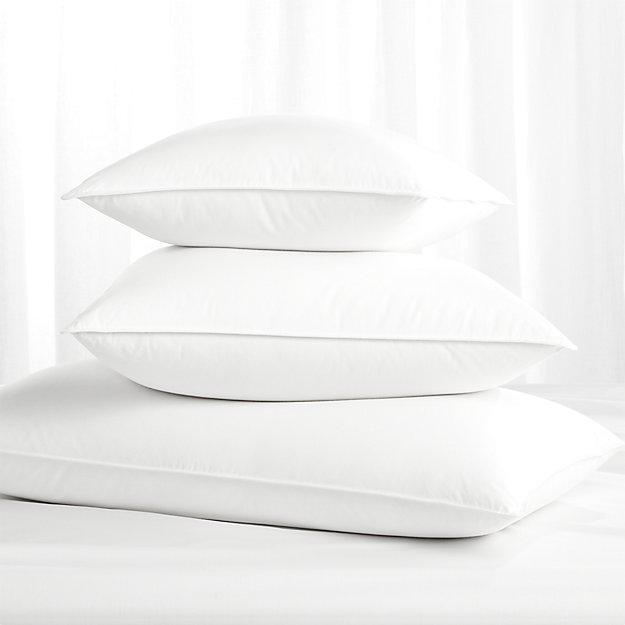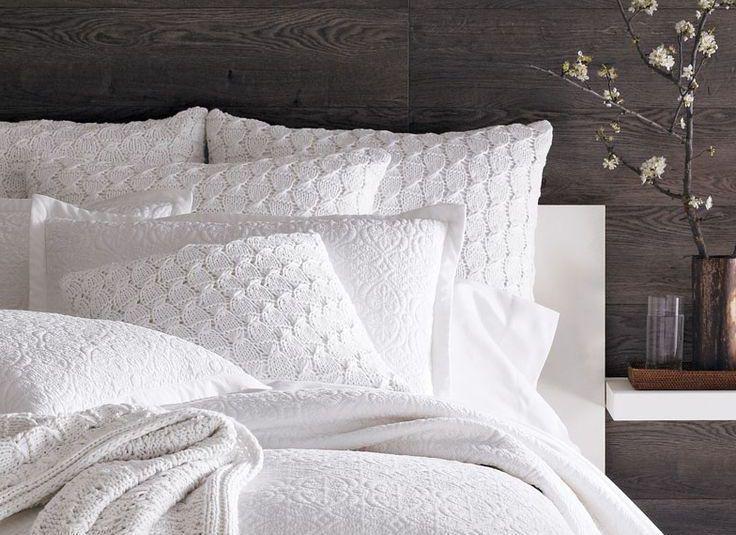The first image is the image on the left, the second image is the image on the right. Assess this claim about the two images: "An image contains exactly three white pillows, and an image shows multiple pillows on a bed with a white blanket.". Correct or not? Answer yes or no. Yes. The first image is the image on the left, the second image is the image on the right. Given the left and right images, does the statement "There are at most 3 pillows in the pair of images." hold true? Answer yes or no. No. 